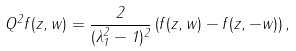<formula> <loc_0><loc_0><loc_500><loc_500>Q ^ { 2 } f ( z , w ) = \frac { 2 } { ( \lambda _ { 1 } ^ { 2 } - 1 ) ^ { 2 } } \left ( f ( z , w ) - f ( z , - w ) \right ) ,</formula> 